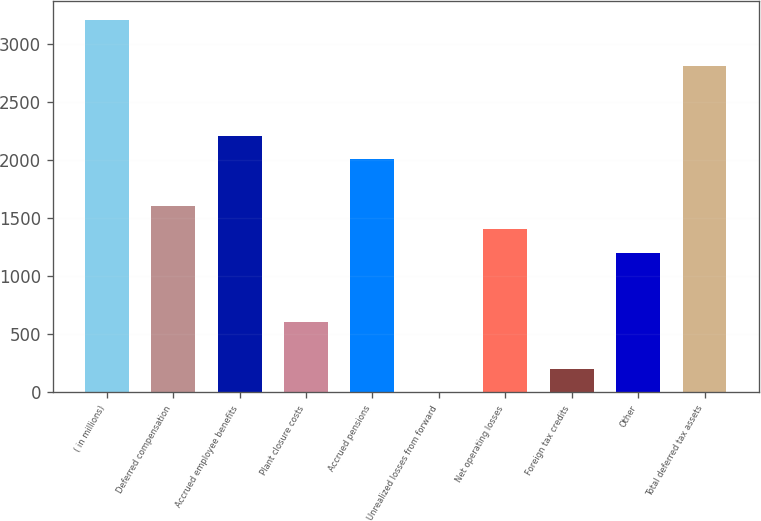Convert chart to OTSL. <chart><loc_0><loc_0><loc_500><loc_500><bar_chart><fcel>( in millions)<fcel>Deferred compensation<fcel>Accrued employee benefits<fcel>Plant closure costs<fcel>Accrued pensions<fcel>Unrealized losses from forward<fcel>Net operating losses<fcel>Foreign tax credits<fcel>Other<fcel>Total deferred tax assets<nl><fcel>3209<fcel>1605<fcel>2206.5<fcel>602.5<fcel>2006<fcel>1<fcel>1404.5<fcel>201.5<fcel>1204<fcel>2808<nl></chart> 